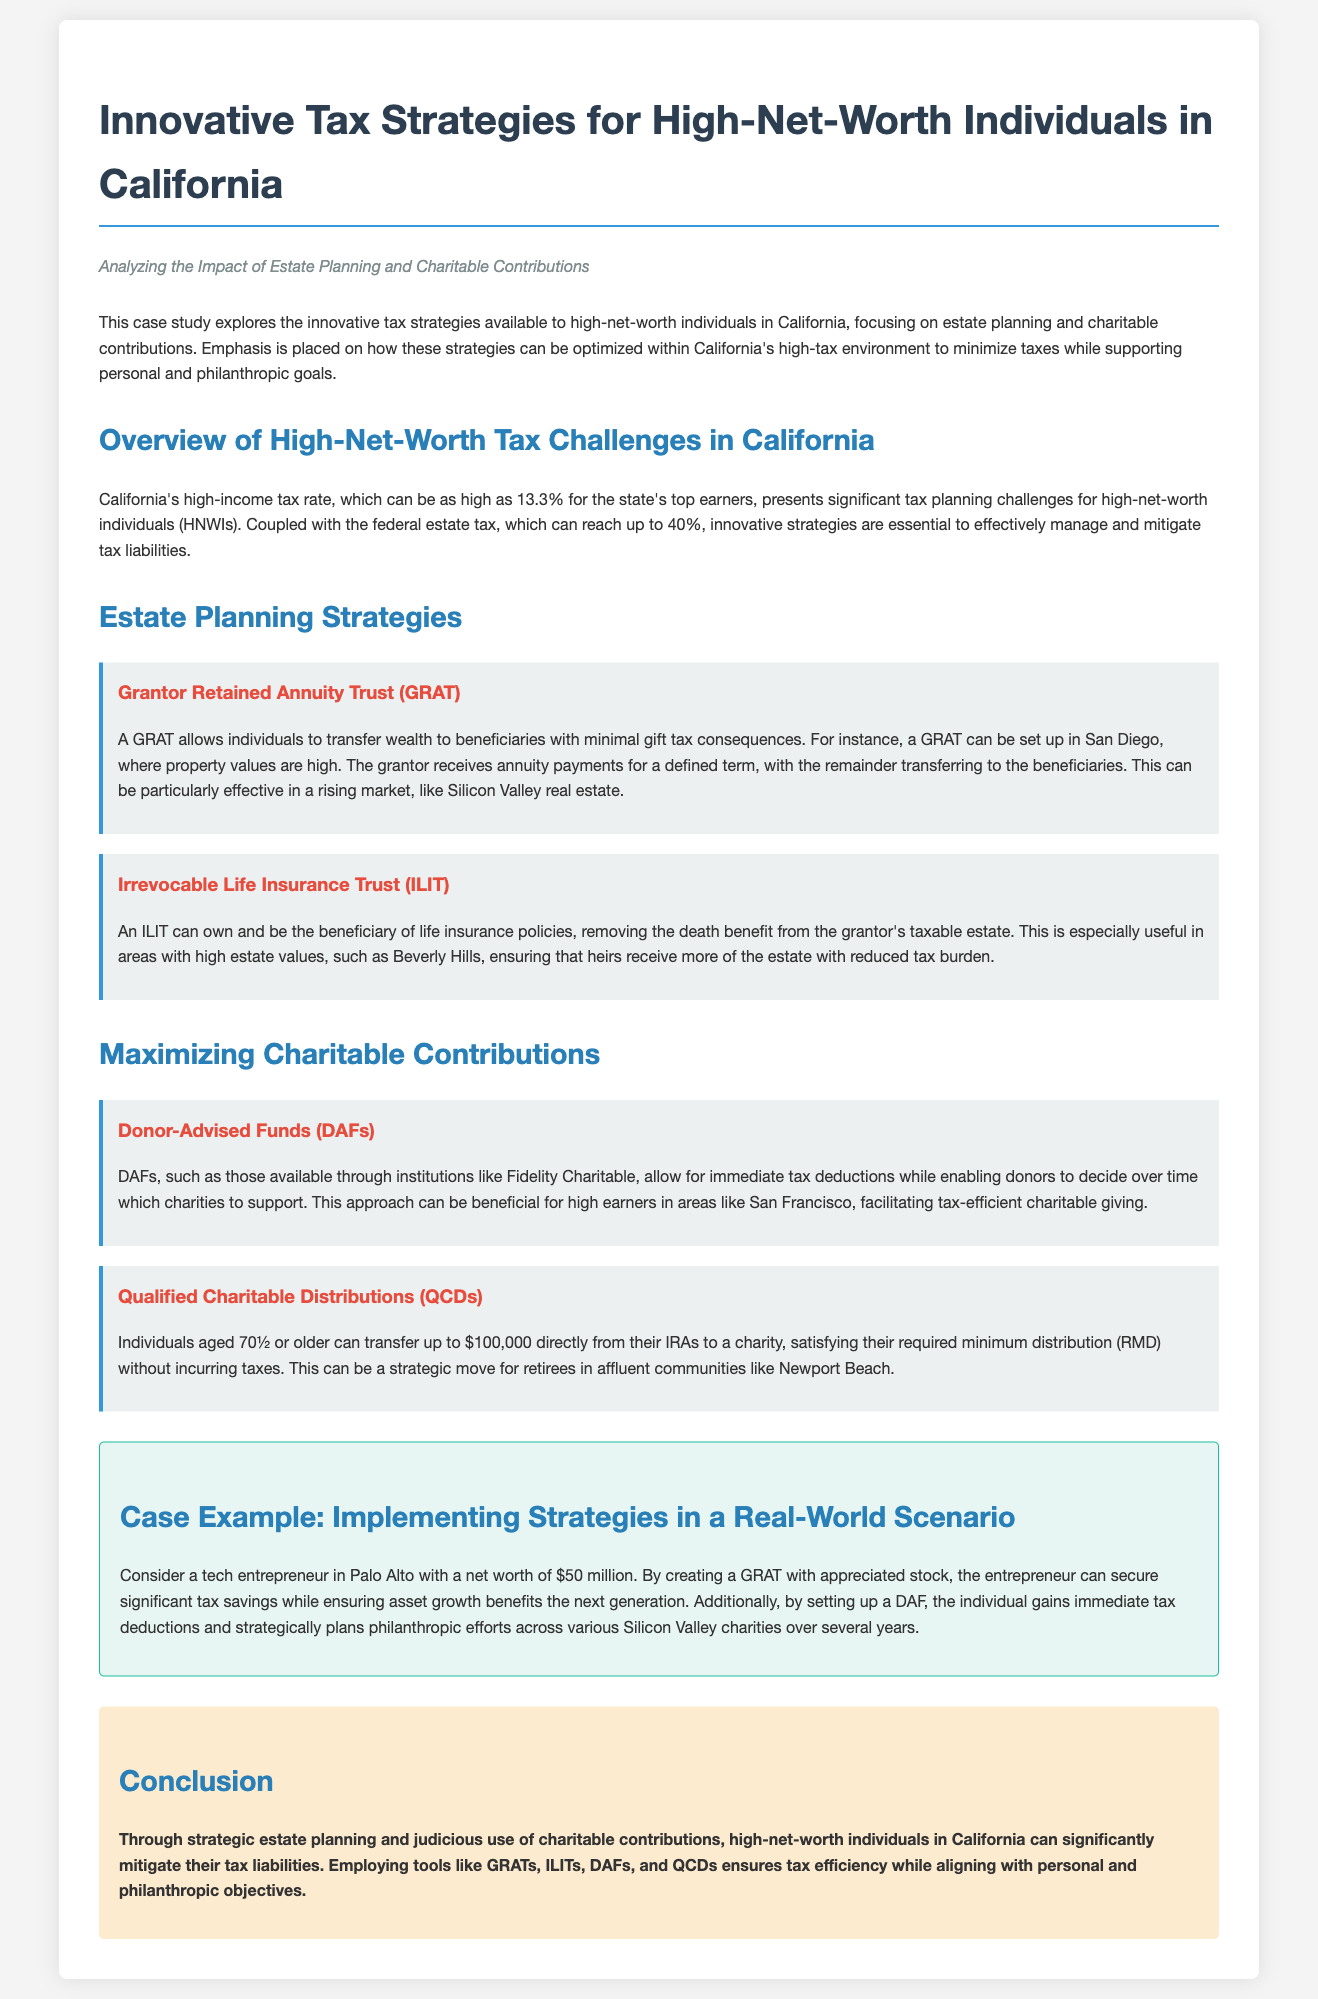What is the maximum income tax rate in California? The document states that California's high-income tax rate can be as high as 13.3% for top earners.
Answer: 13.3% What estate planning tool allows individuals to transfer wealth with minimal gift tax? The strategy described in the document for transferring wealth with minimal gift tax consequences is a Grantor Retained Annuity Trust (GRAT).
Answer: GRAT What is the purpose of an Irrevocable Life Insurance Trust (ILIT)? The document explains that an ILIT can remove the death benefit from the grantor's taxable estate, ensuring that heirs receive more.
Answer: Remove death benefit from taxable estate How much can individuals aged 70½ or older transfer from their IRAs to charity tax-free? According to the document, individuals aged 70½ or older can transfer up to $100,000 directly from their IRAs to charity.
Answer: $100,000 What case example involves a tech entrepreneur's strategies for tax savings? The document mentions a tech entrepreneur in Palo Alto with a net worth of $50 million as a case example.
Answer: Tech entrepreneur in Palo Alto What strategy facilitates immediate tax deductions while allowing control over philanthropic contributions? The document identifies Donor-Advised Funds (DAFs) as a strategy that allows for immediate tax deductions while deciding which charities to support.
Answer: Donor-Advised Funds (DAFs) Which affluent community is mentioned for the Qualified Charitable Distributions (QCDs) strategy? The document references Newport Beach as an affluent community where this strategy can be beneficial for retirees.
Answer: Newport Beach What is the primary focus of the case study? The primary focus of the case study is on innovative tax strategies available to high-net-worth individuals in California.
Answer: Innovative tax strategies for HNWIs in California 